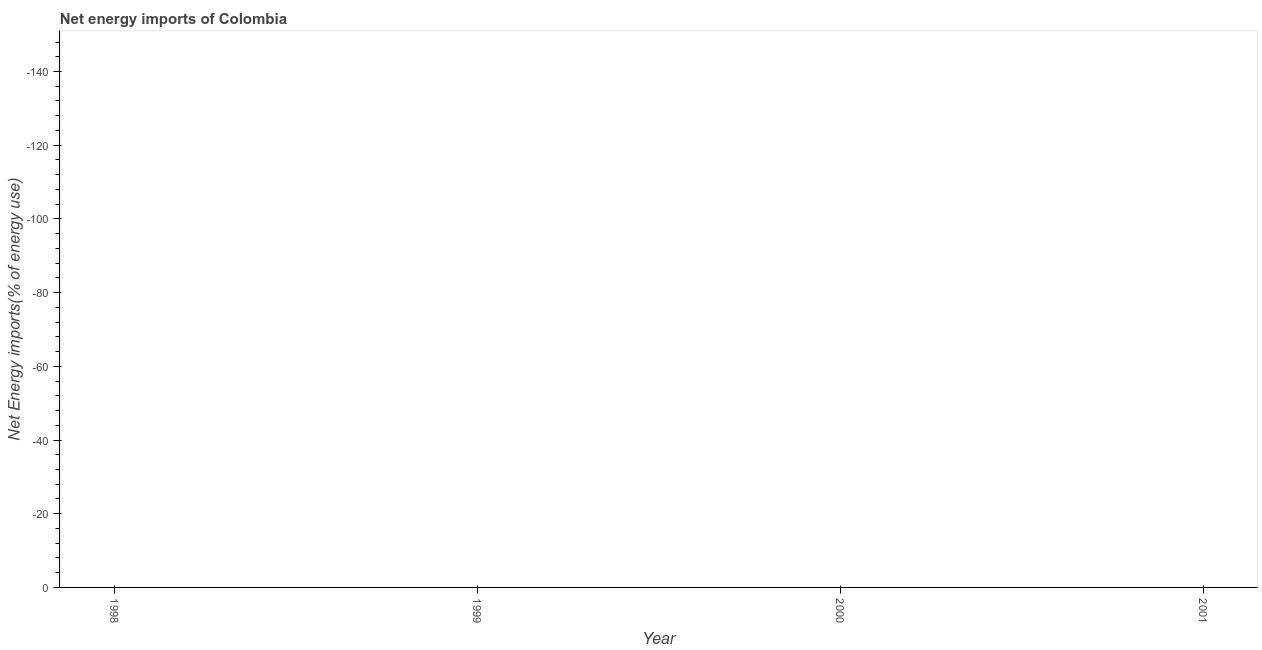What is the sum of the energy imports?
Give a very brief answer. 0. What is the average energy imports per year?
Offer a very short reply. 0. In how many years, is the energy imports greater than -28 %?
Ensure brevity in your answer.  0. How many dotlines are there?
Your response must be concise. 0. How many years are there in the graph?
Offer a terse response. 4. What is the difference between two consecutive major ticks on the Y-axis?
Offer a very short reply. 20. Are the values on the major ticks of Y-axis written in scientific E-notation?
Offer a terse response. No. What is the title of the graph?
Provide a short and direct response. Net energy imports of Colombia. What is the label or title of the X-axis?
Provide a succinct answer. Year. What is the label or title of the Y-axis?
Provide a short and direct response. Net Energy imports(% of energy use). What is the Net Energy imports(% of energy use) in 1998?
Your response must be concise. 0. What is the Net Energy imports(% of energy use) in 1999?
Give a very brief answer. 0. What is the Net Energy imports(% of energy use) in 2001?
Give a very brief answer. 0. 